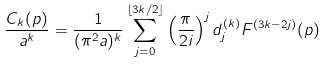Convert formula to latex. <formula><loc_0><loc_0><loc_500><loc_500>\frac { C _ { k } ( p ) } { a ^ { k } } = \frac { 1 } { ( \pi ^ { 2 } a ) ^ { k } } \sum _ { j = 0 } ^ { \lfloor 3 k / 2 \rfloor } \left ( \frac { \pi } { 2 i } \right ) ^ { j } d ^ { ( k ) } _ { j } F ^ { ( 3 k - 2 j ) } ( p )</formula> 